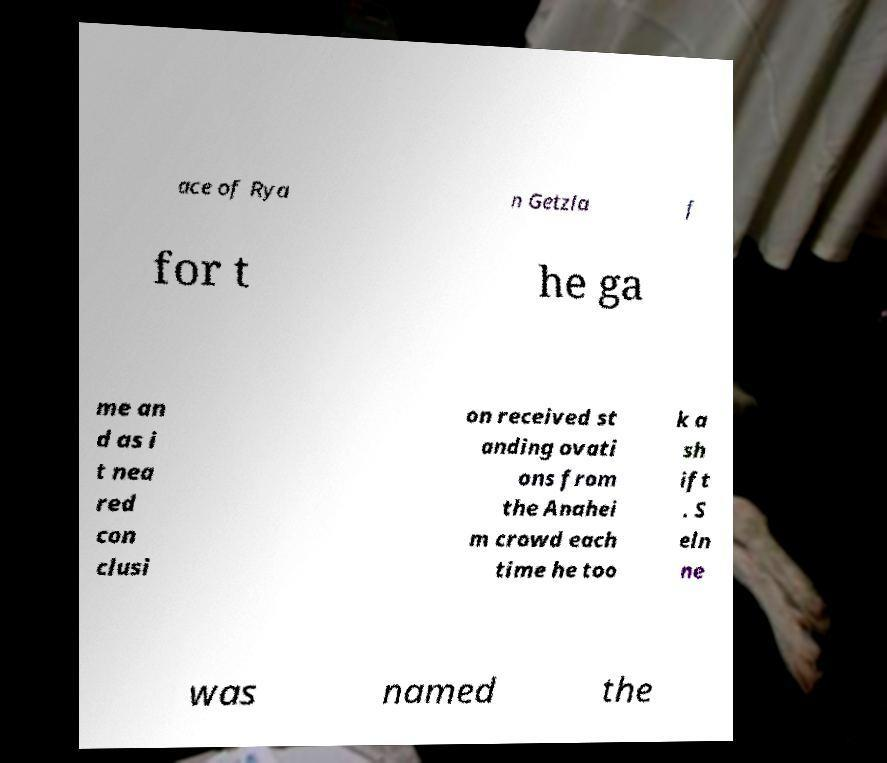What messages or text are displayed in this image? I need them in a readable, typed format. ace of Rya n Getzla f for t he ga me an d as i t nea red con clusi on received st anding ovati ons from the Anahei m crowd each time he too k a sh ift . S eln ne was named the 